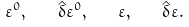Convert formula to latex. <formula><loc_0><loc_0><loc_500><loc_500>\varepsilon ^ { 0 } , \quad \hat { \delta } \varepsilon ^ { 0 } , \quad \varepsilon , \quad \hat { \delta } \varepsilon .</formula> 